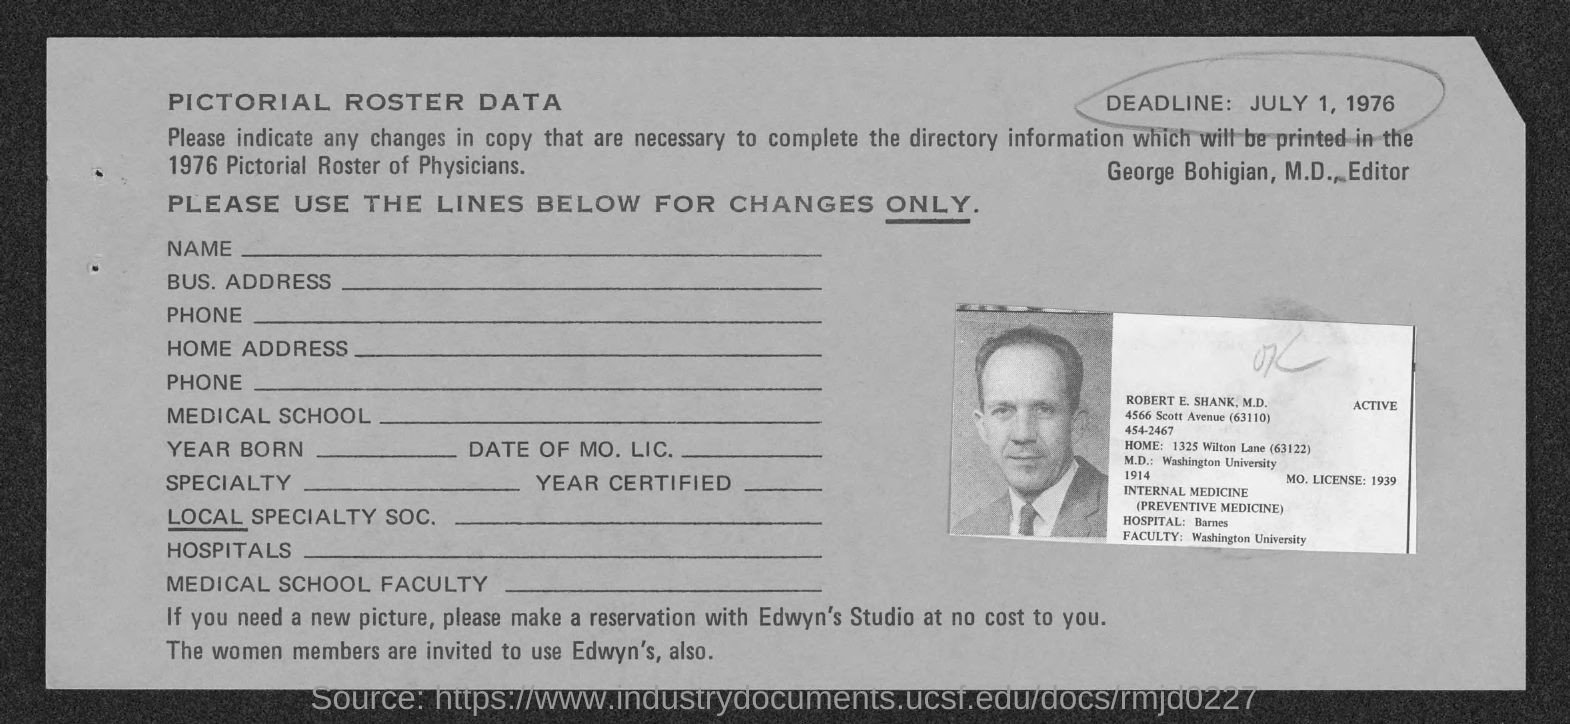What is the deadline ?
Your answer should be very brief. July 1, 1976. What is the mo. license no.?
Make the answer very short. 1939. What is the home address of robert e. shank ?
Keep it short and to the point. 1325 wilton lane (63122). Where did robert e. shank complete his m.d. from ?
Provide a short and direct response. Washington University. What is the hospital where robert e. shank work at ?
Keep it short and to the point. Barnes. Where do robert e. shank work as faculty ?
Offer a terse response. Washington University. 